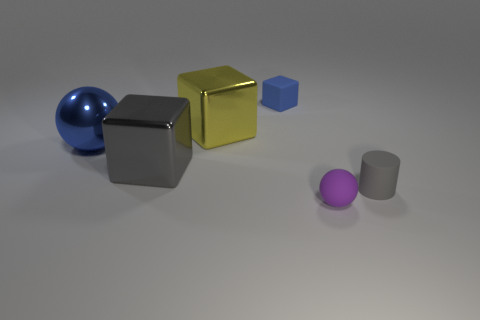Add 1 big green metallic blocks. How many objects exist? 7 Subtract all cylinders. How many objects are left? 5 Subtract all tiny balls. Subtract all tiny purple rubber spheres. How many objects are left? 4 Add 6 purple spheres. How many purple spheres are left? 7 Add 4 big green cylinders. How many big green cylinders exist? 4 Subtract 0 yellow cylinders. How many objects are left? 6 